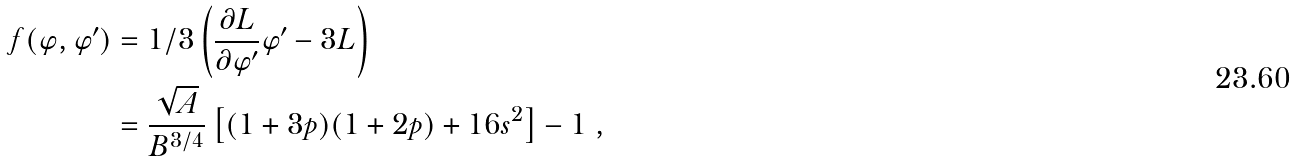<formula> <loc_0><loc_0><loc_500><loc_500>f ( \varphi , \varphi ^ { \prime } ) & = 1 / 3 \left ( \frac { \partial L } { \partial \varphi ^ { \prime } } \varphi ^ { \prime } - 3 L \right ) \\ & = \frac { \sqrt { A } } { B ^ { 3 / 4 } } \left [ ( 1 + 3 p ) ( 1 + 2 p ) + 1 6 s ^ { 2 } \right ] - 1 \ ,</formula> 